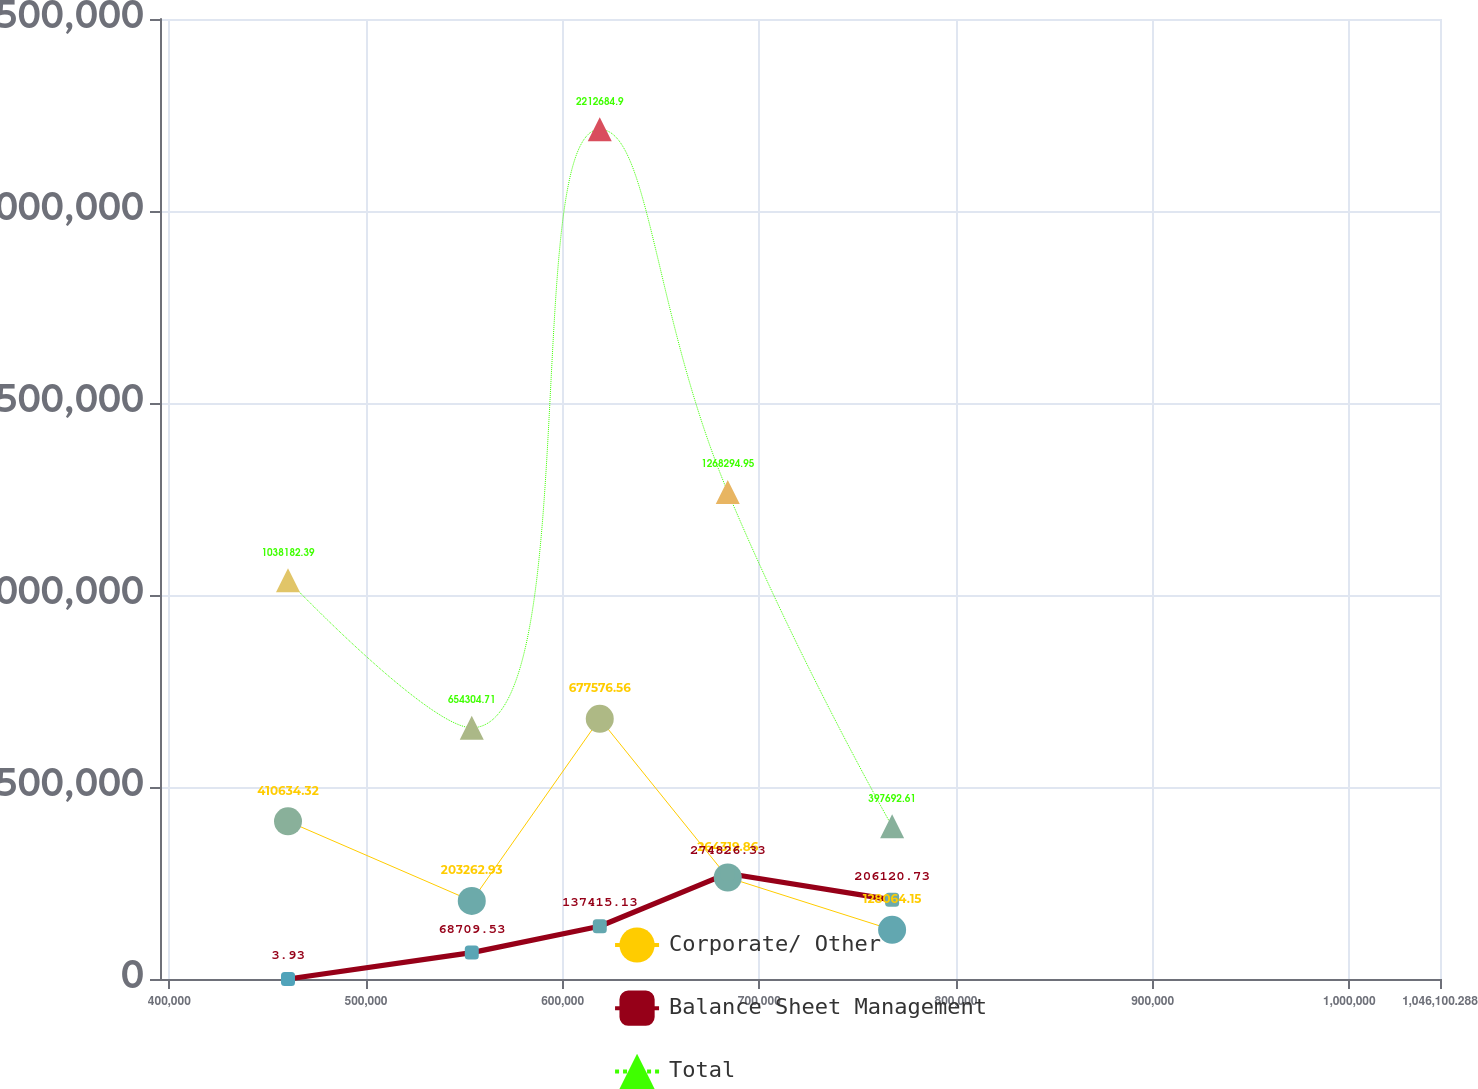Convert chart to OTSL. <chart><loc_0><loc_0><loc_500><loc_500><line_chart><ecel><fcel>Corporate/ Other<fcel>Balance Sheet Management<fcel>Total<nl><fcel>460331<fcel>410634<fcel>3.93<fcel>1.03818e+06<nl><fcel>553776<fcel>203263<fcel>68709.5<fcel>654305<nl><fcel>618862<fcel>677577<fcel>137415<fcel>2.21268e+06<nl><fcel>683947<fcel>264320<fcel>274826<fcel>1.26829e+06<nl><fcel>767506<fcel>128064<fcel>206121<fcel>397693<nl><fcel>1.11119e+06<fcel>67007.2<fcel>687060<fcel>109532<nl></chart> 